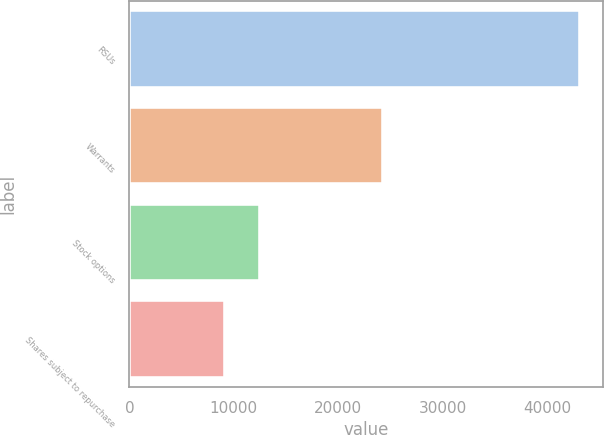<chart> <loc_0><loc_0><loc_500><loc_500><bar_chart><fcel>RSUs<fcel>Warrants<fcel>Stock options<fcel>Shares subject to repurchase<nl><fcel>43170<fcel>24329<fcel>12548.4<fcel>9146<nl></chart> 